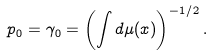<formula> <loc_0><loc_0><loc_500><loc_500>p _ { 0 } = \gamma _ { 0 } = \left ( \int d \mu ( x ) \right ) ^ { - 1 / 2 } .</formula> 